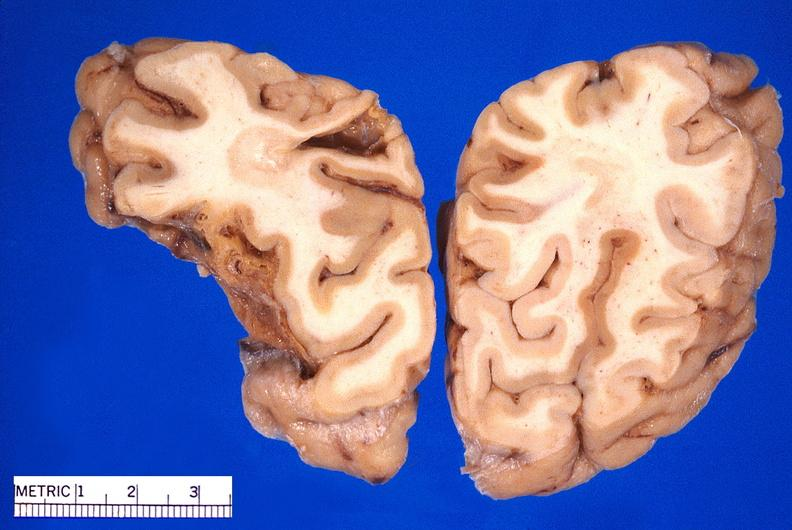s metastatic adenocarcinoma present?
Answer the question using a single word or phrase. No 